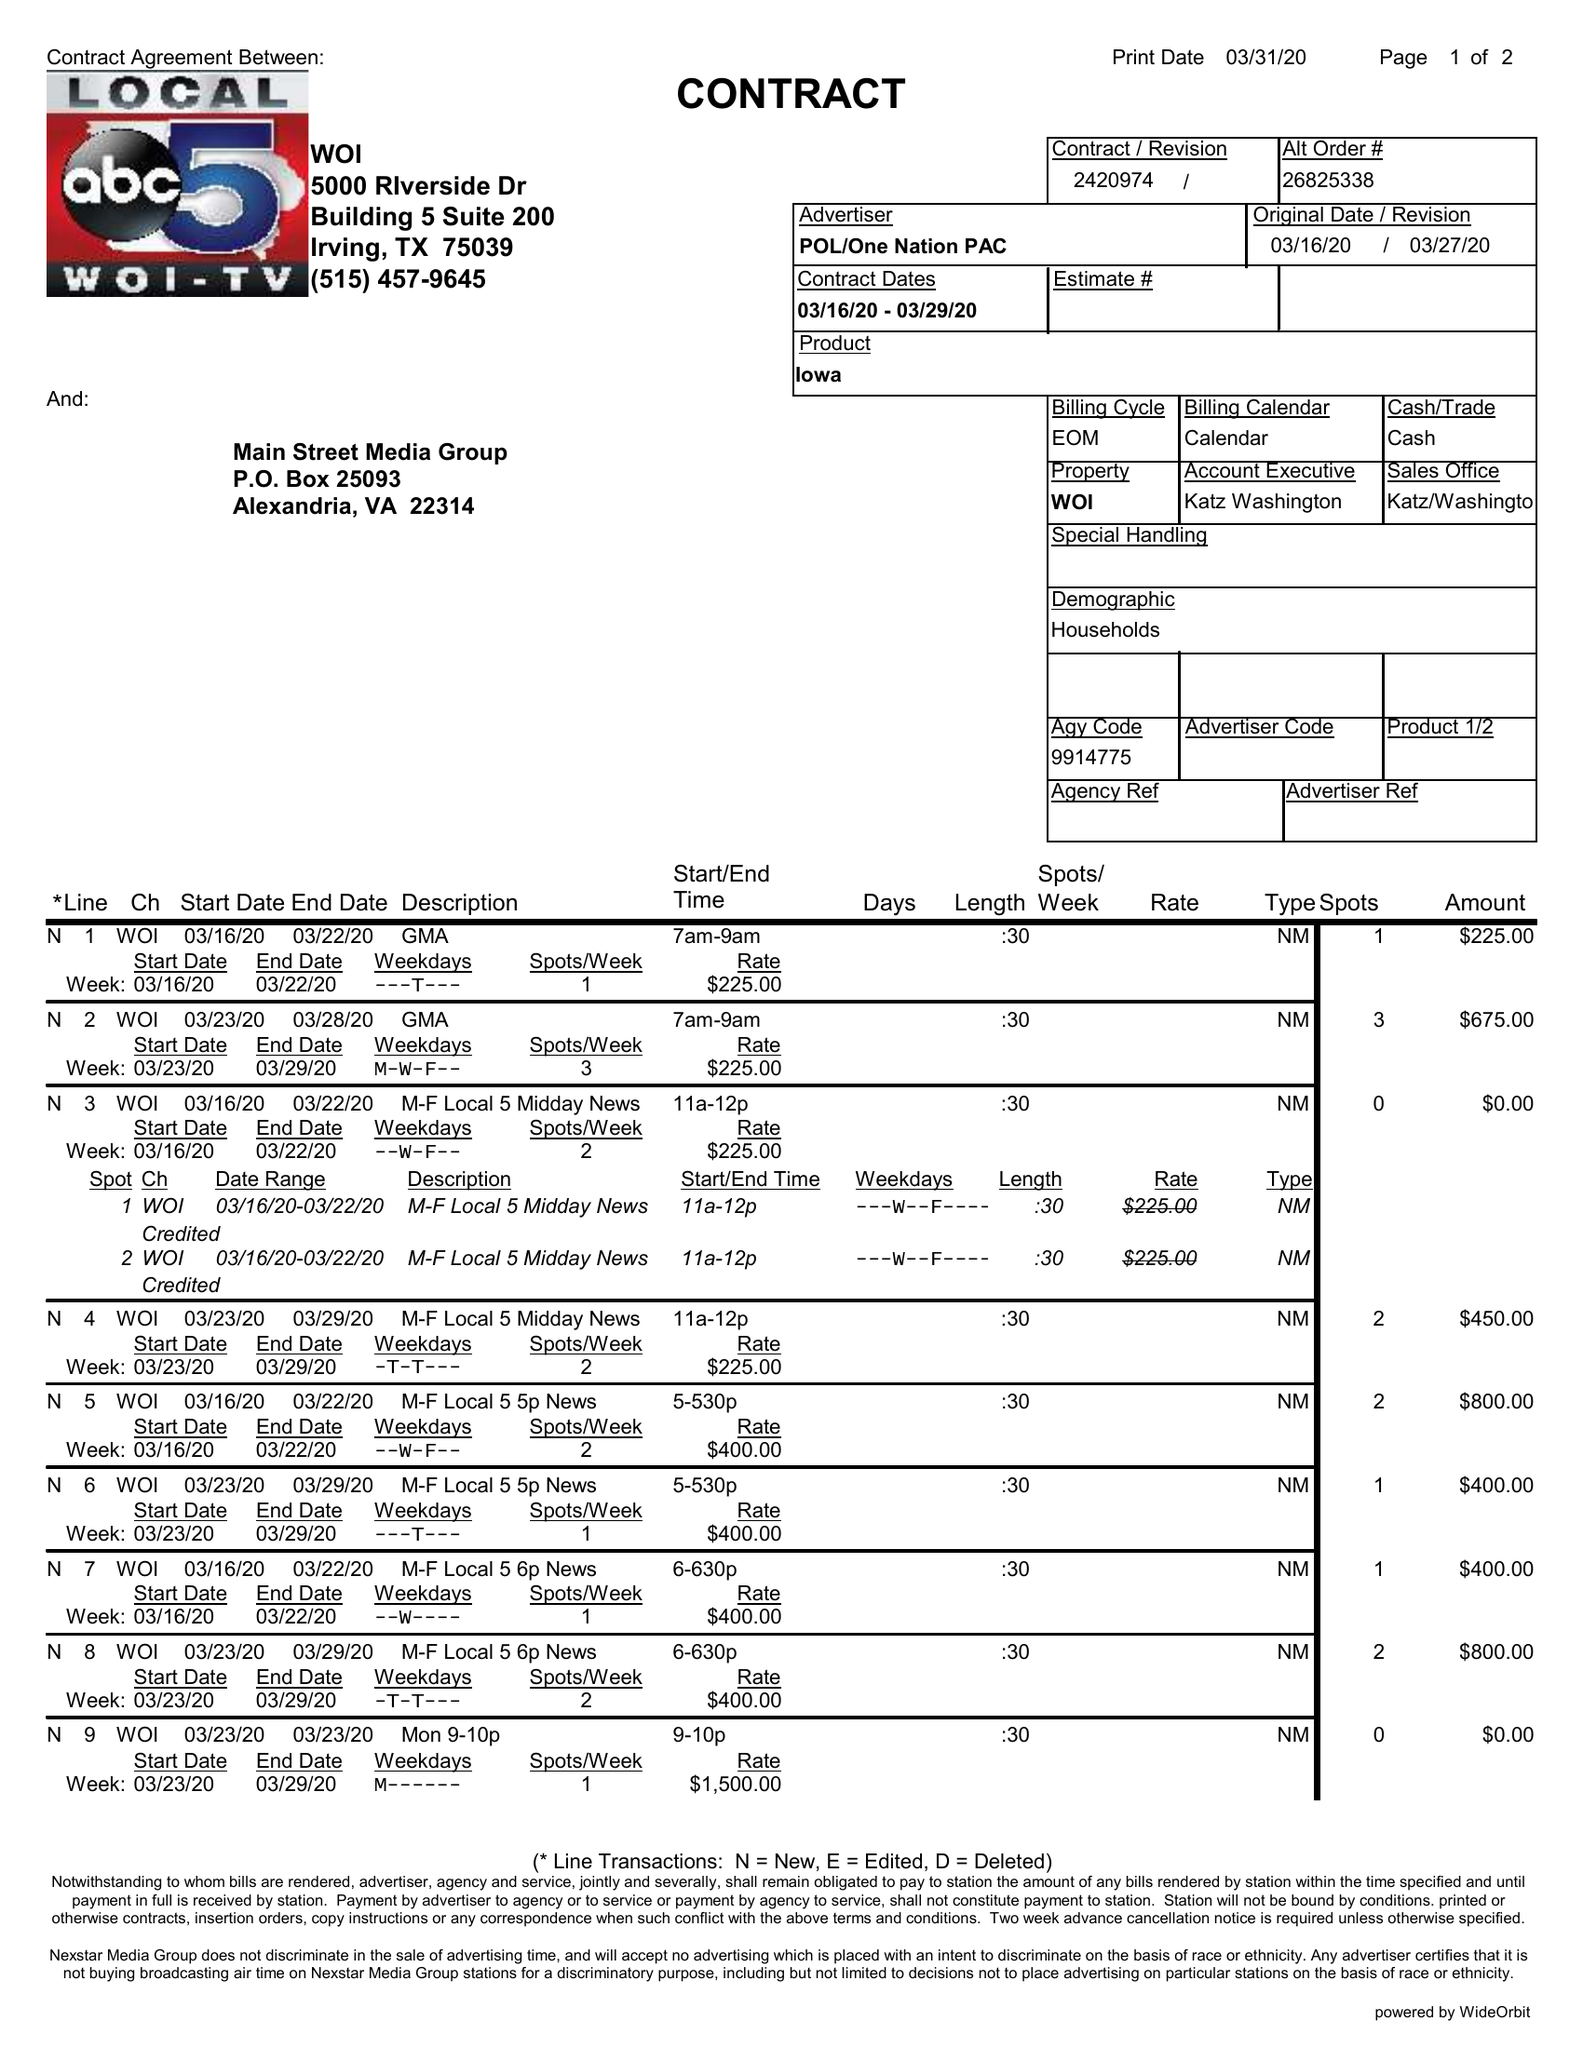What is the value for the gross_amount?
Answer the question using a single word or phrase. 11825.00 